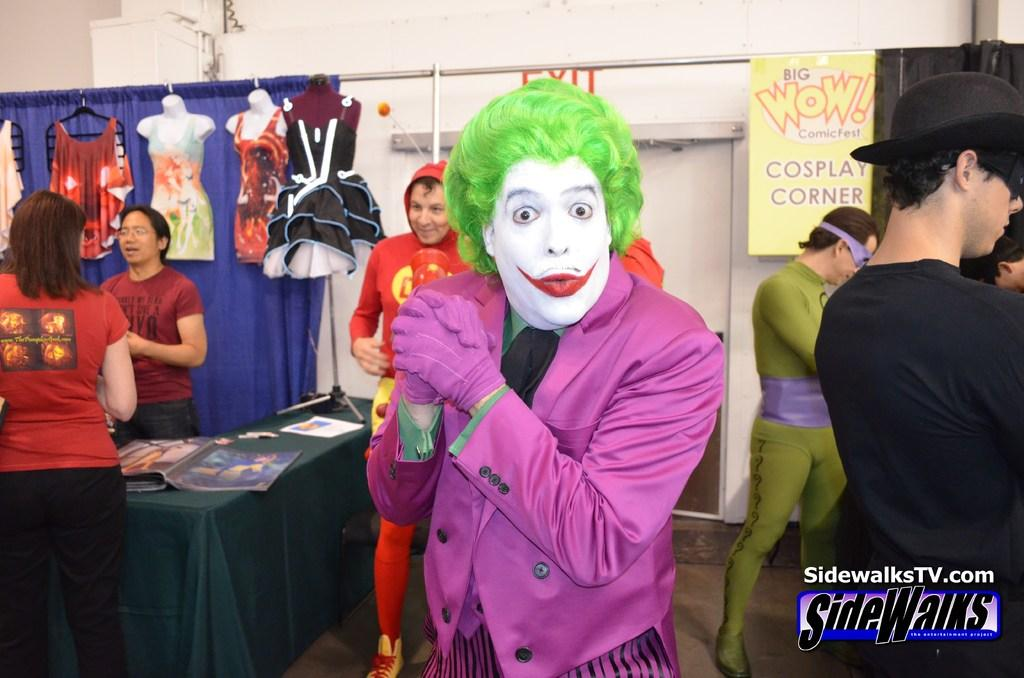<image>
Present a compact description of the photo's key features. The word exit can be seen on the wall above the person dressed as a joker. 